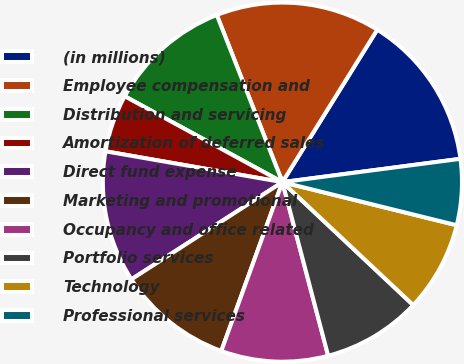Convert chart to OTSL. <chart><loc_0><loc_0><loc_500><loc_500><pie_chart><fcel>(in millions)<fcel>Employee compensation and<fcel>Distribution and servicing<fcel>Amortization of deferred sales<fcel>Direct fund expense<fcel>Marketing and promotional<fcel>Occupancy and office related<fcel>Portfolio services<fcel>Technology<fcel>Professional services<nl><fcel>14.07%<fcel>14.81%<fcel>11.11%<fcel>5.19%<fcel>11.85%<fcel>10.37%<fcel>9.63%<fcel>8.89%<fcel>8.15%<fcel>5.93%<nl></chart> 